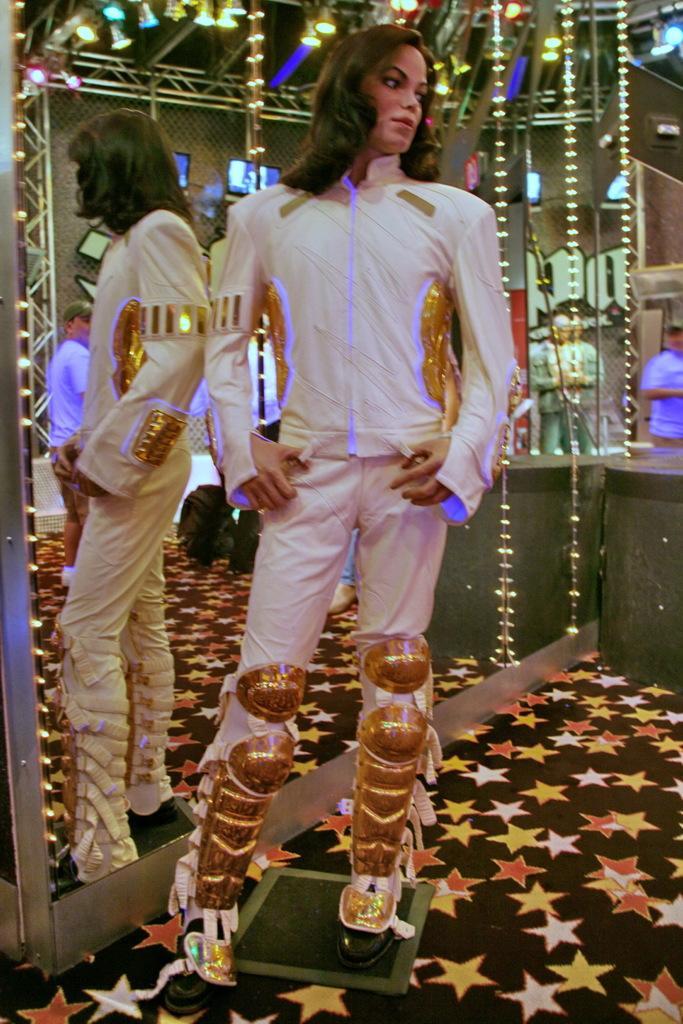Could you give a brief overview of what you see in this image? In this picture we can see a person standing and posing. He is standing on a doormat. We can see a few stars on a black surface. There is a glass at the back of this person. We can see the reflection of this person and a man through this glass. There are a few lights visible and a man in the background. 